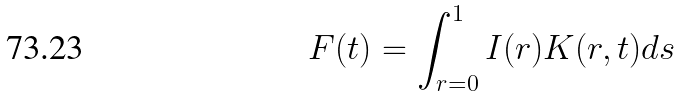Convert formula to latex. <formula><loc_0><loc_0><loc_500><loc_500>F ( t ) = \int _ { r = 0 } ^ { 1 } I ( r ) K ( r , t ) d s</formula> 